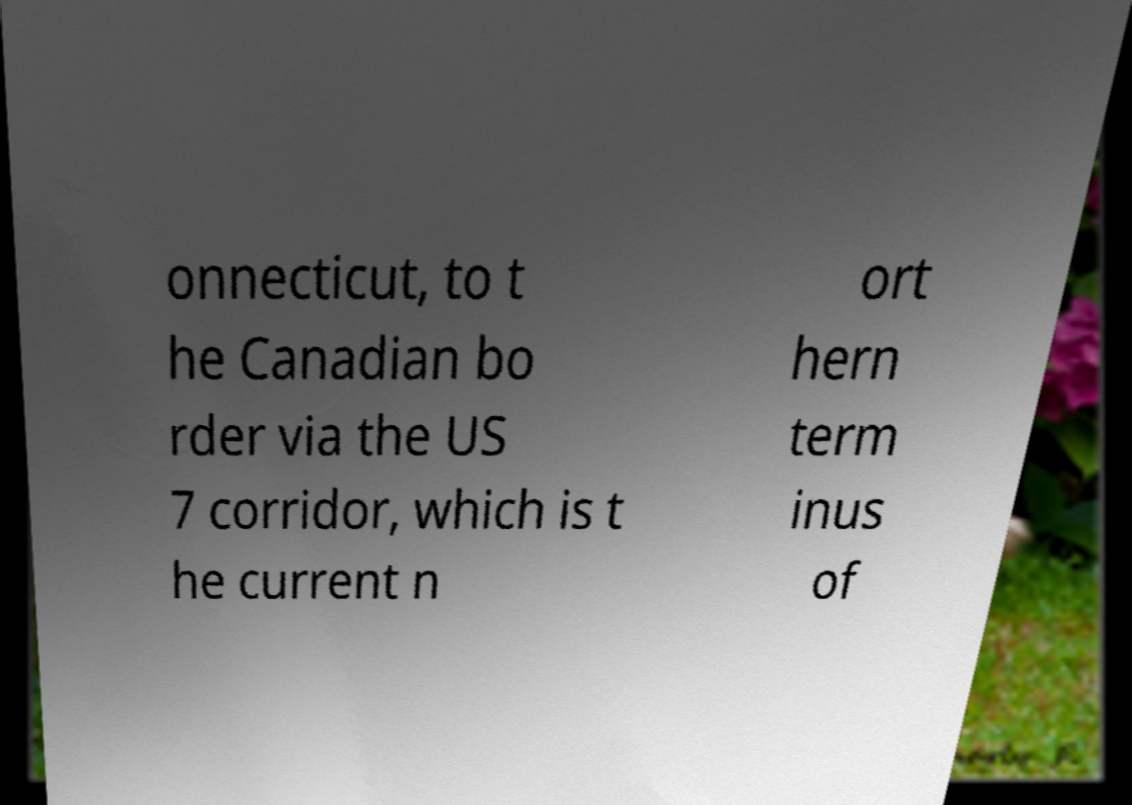Please identify and transcribe the text found in this image. onnecticut, to t he Canadian bo rder via the US 7 corridor, which is t he current n ort hern term inus of 